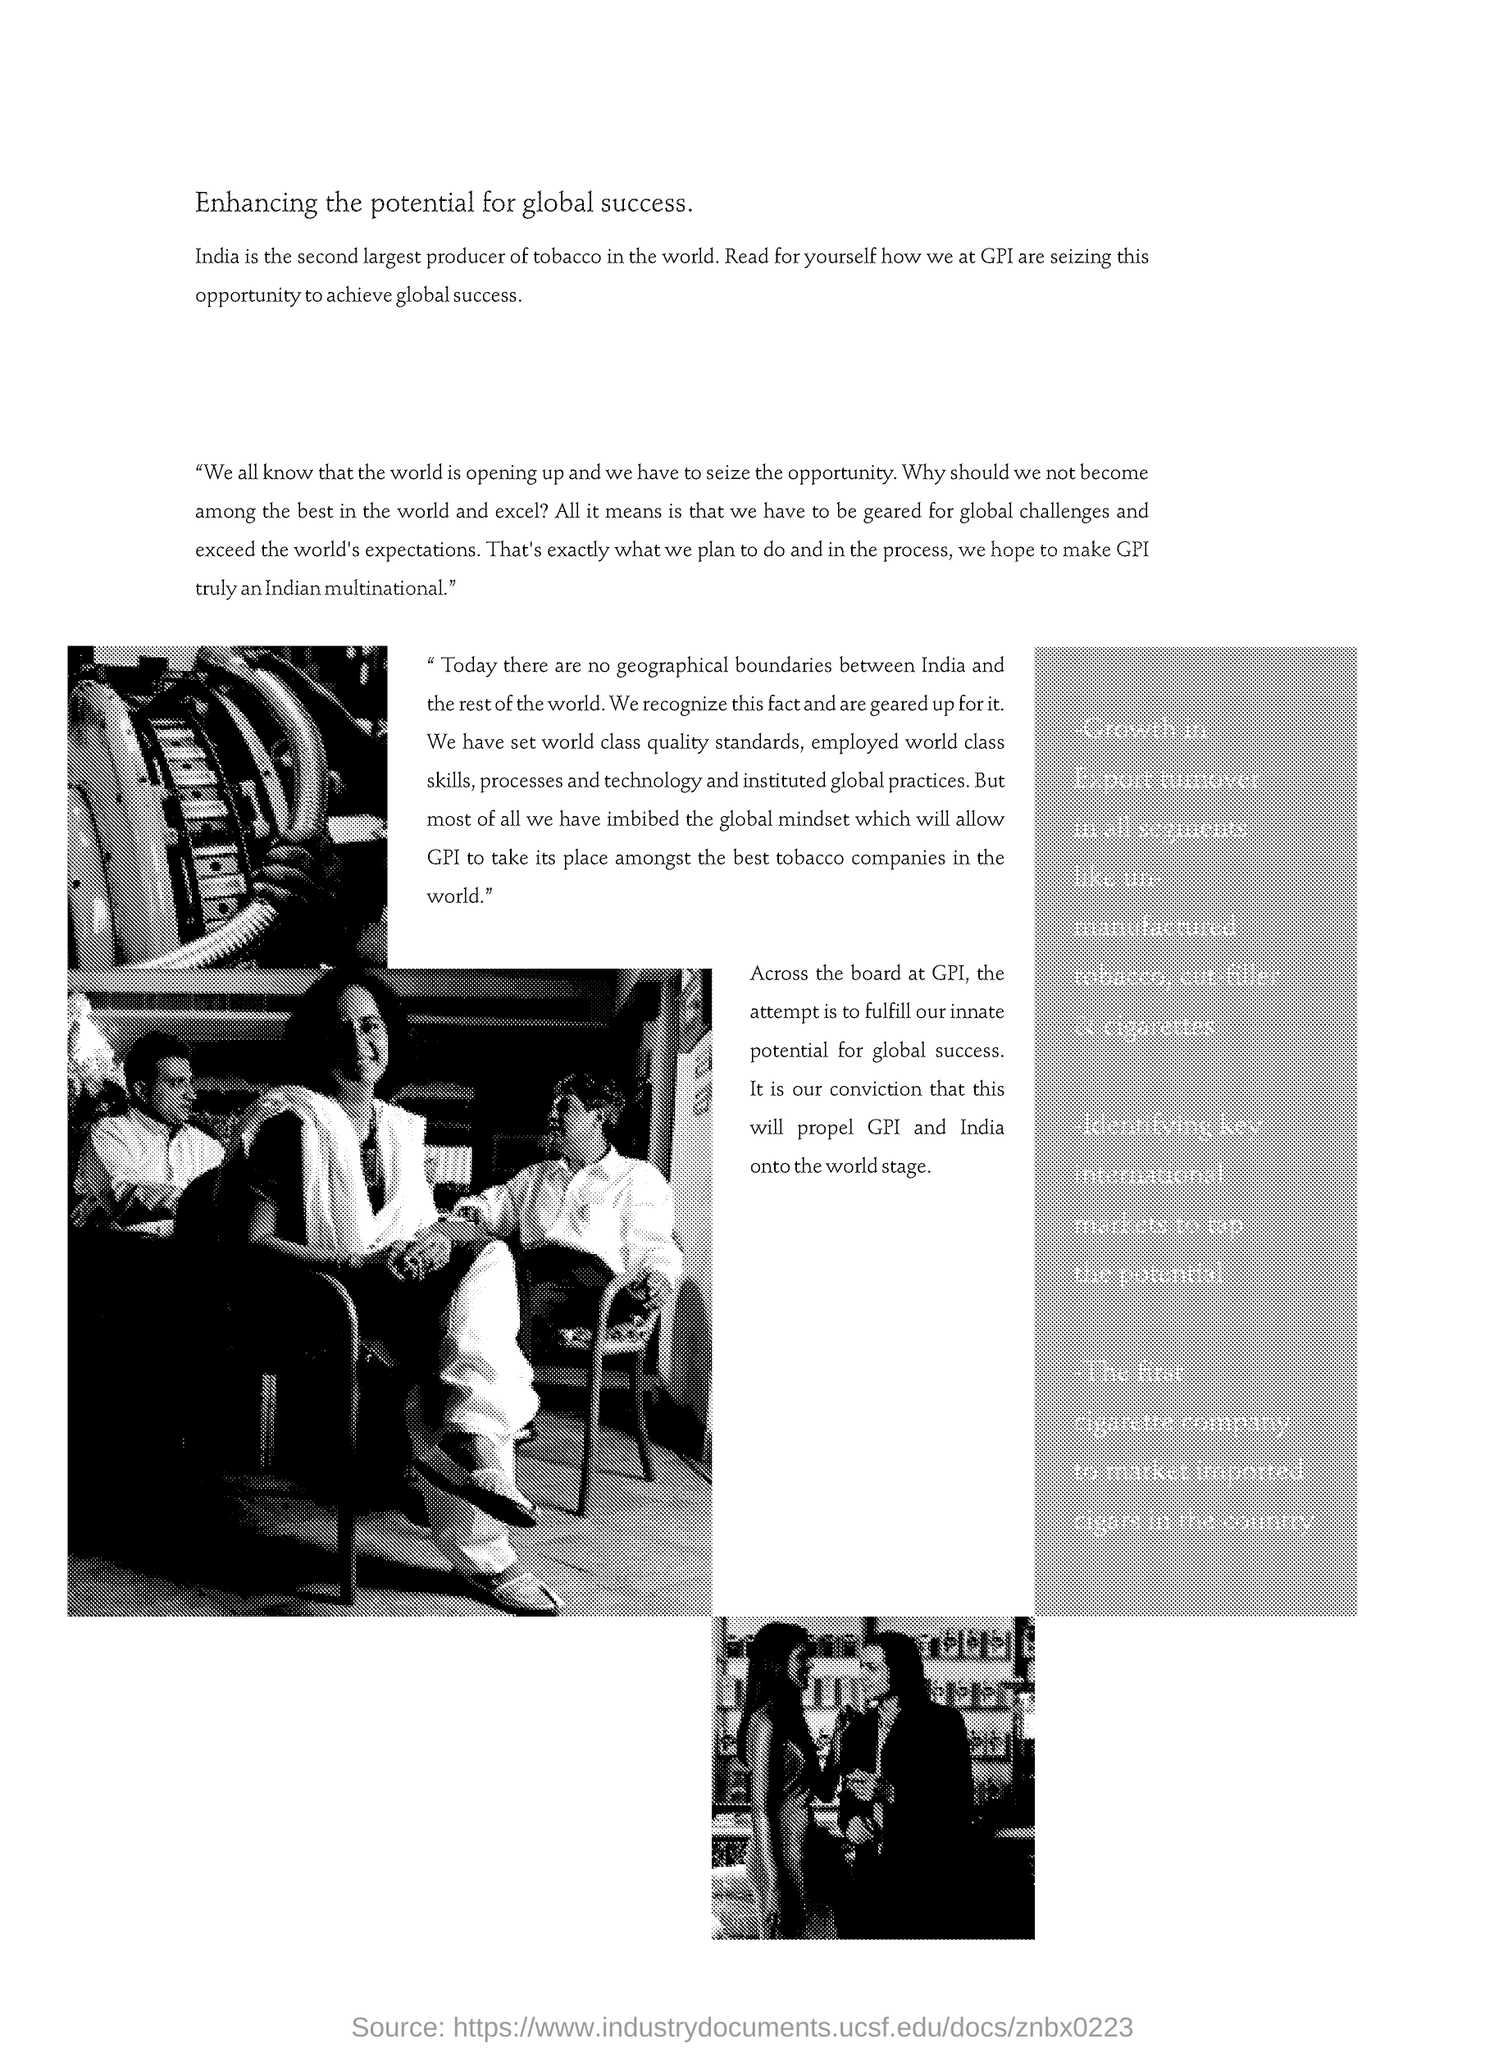Which country is the second largest producer of tobacco in the world?
Offer a terse response. India. 